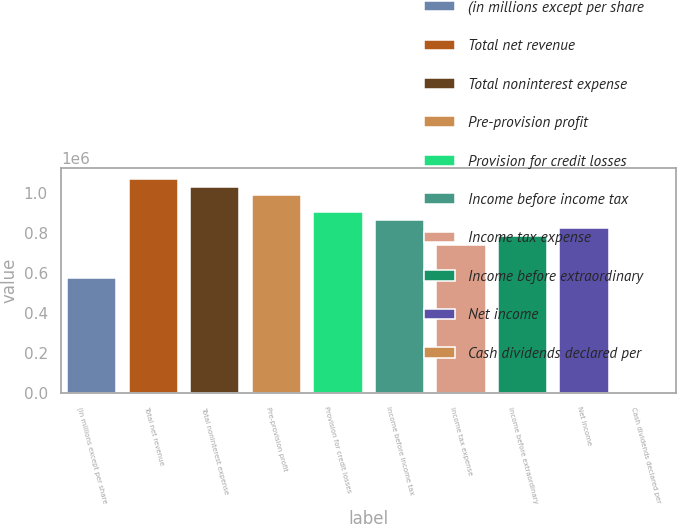Convert chart. <chart><loc_0><loc_0><loc_500><loc_500><bar_chart><fcel>(in millions except per share<fcel>Total net revenue<fcel>Total noninterest expense<fcel>Pre-provision profit<fcel>Provision for credit losses<fcel>Income before income tax<fcel>Income tax expense<fcel>Income before extraordinary<fcel>Net income<fcel>Cash dividends declared per<nl><fcel>575579<fcel>1.06893e+06<fcel>1.02782e+06<fcel>986707<fcel>904481<fcel>863369<fcel>740030<fcel>781143<fcel>822256<fcel>0.2<nl></chart> 